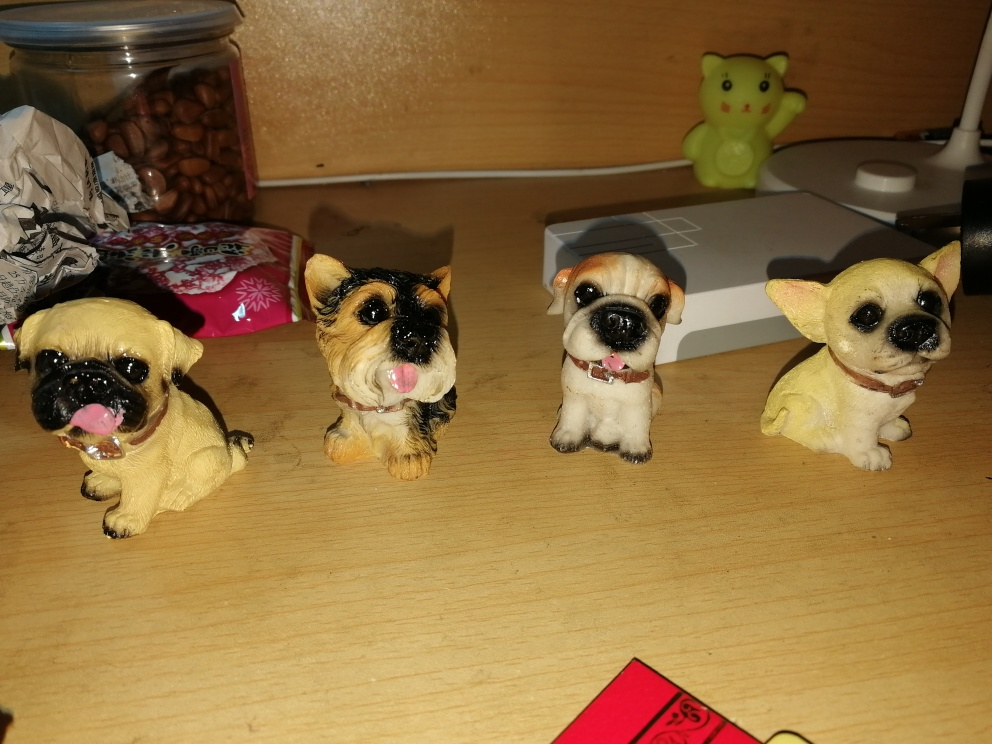What could be the purpose or usage of these dog figurines? These dog figurines can serve multiple purposes. They may be part of a collector's display, adding a whimsical touch to someone's décor. Additionally, they could be used as toys for children, educational tools for teaching about different dog breeds, or as sentimental keepsakes for dog enthusiasts. Their presence adds personality and charm to the setting. 